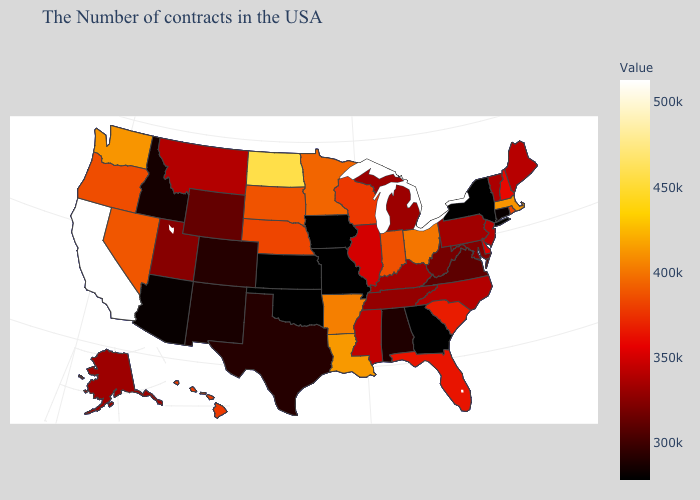Does South Dakota have a higher value than California?
Write a very short answer. No. Which states hav the highest value in the Northeast?
Give a very brief answer. Massachusetts. Which states have the lowest value in the West?
Concise answer only. Arizona. 